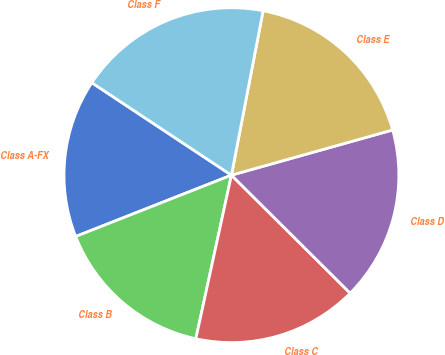Convert chart to OTSL. <chart><loc_0><loc_0><loc_500><loc_500><pie_chart><fcel>Class A-FX<fcel>Class B<fcel>Class C<fcel>Class D<fcel>Class E<fcel>Class F<nl><fcel>15.28%<fcel>15.62%<fcel>15.96%<fcel>16.8%<fcel>17.62%<fcel>18.72%<nl></chart> 